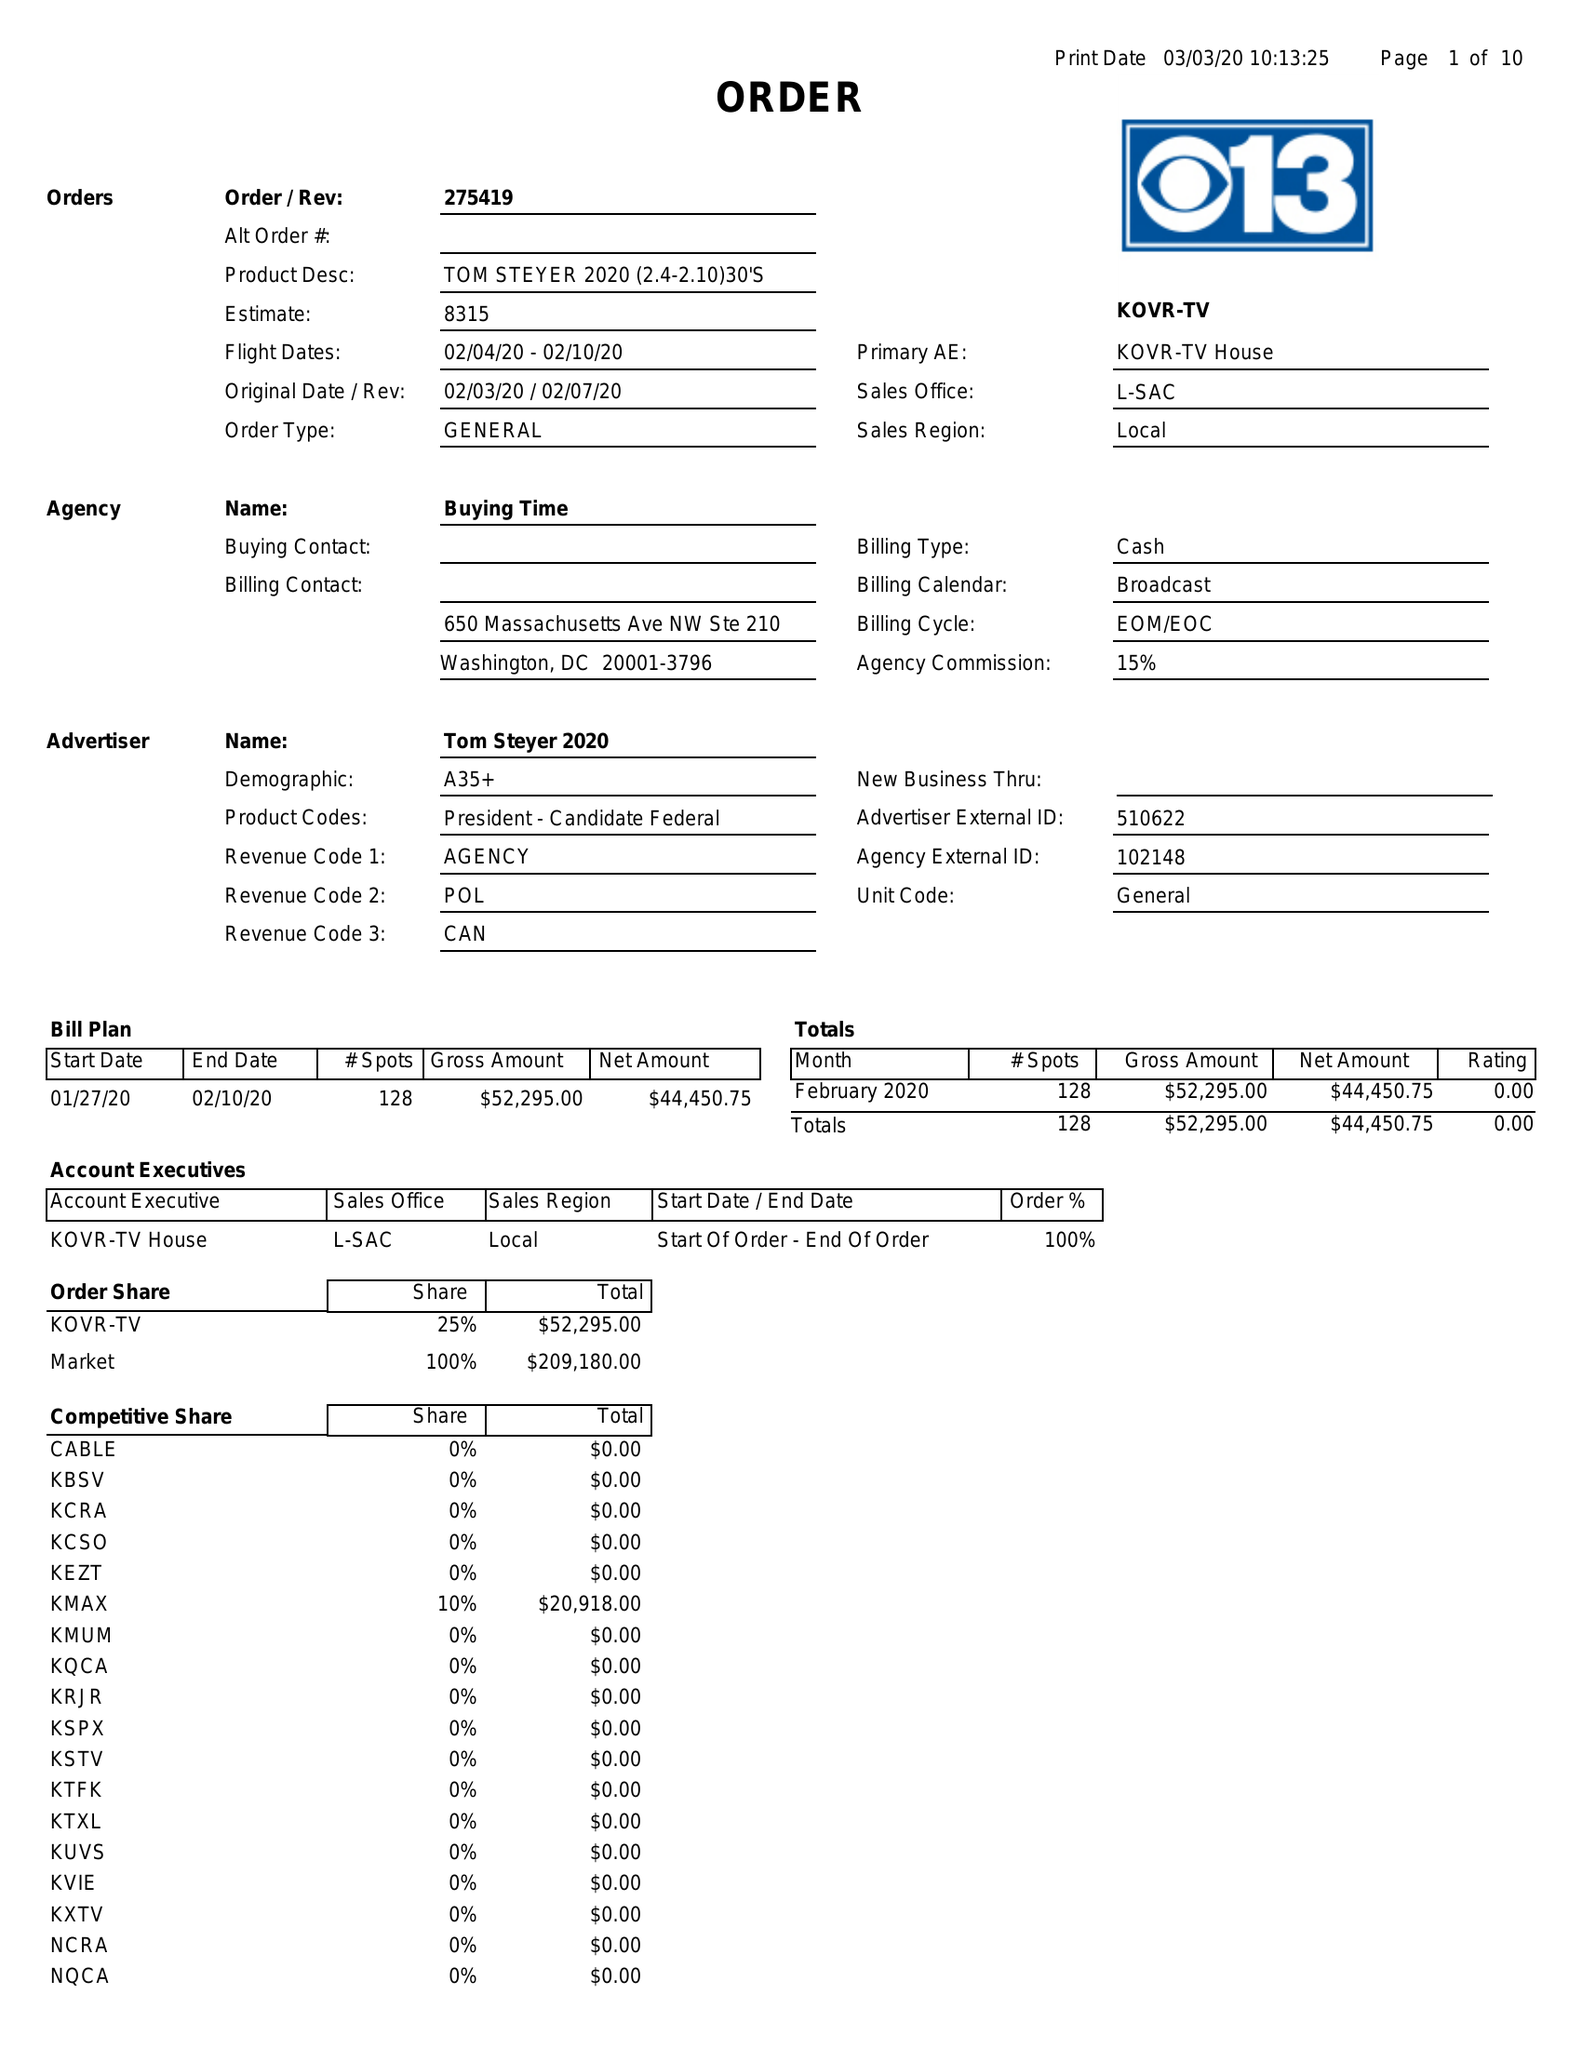What is the value for the flight_to?
Answer the question using a single word or phrase. 02/10/20 